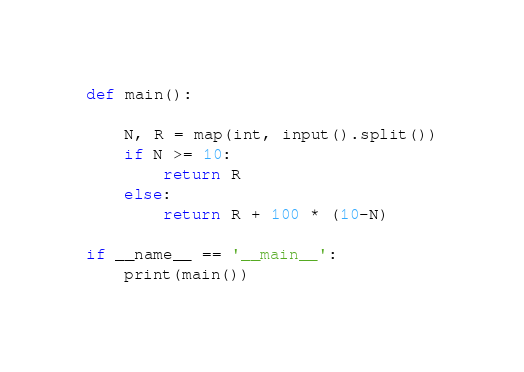Convert code to text. <code><loc_0><loc_0><loc_500><loc_500><_Python_>def main():

    N, R = map(int, input().split())
    if N >= 10:
        return R
    else:
        return R + 100 * (10-N)

if __name__ == '__main__':
    print(main())
</code> 